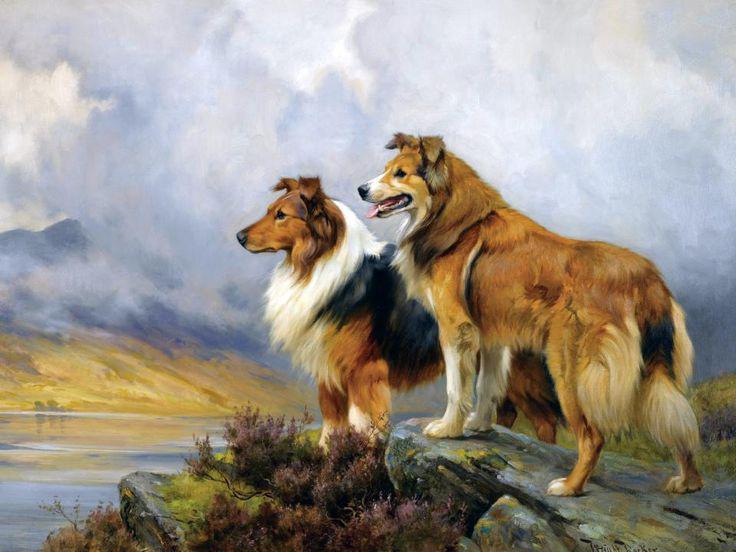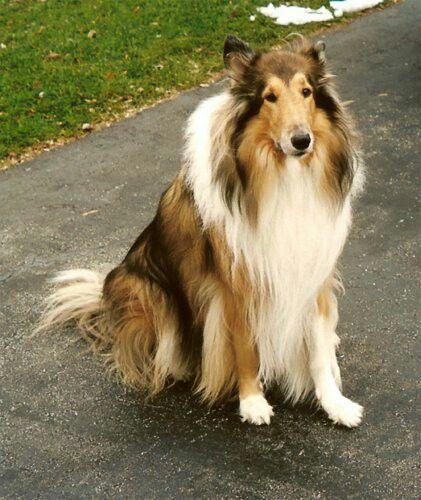The first image is the image on the left, the second image is the image on the right. Given the left and right images, does the statement "There are three dogs outside." hold true? Answer yes or no. Yes. 